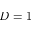Convert formula to latex. <formula><loc_0><loc_0><loc_500><loc_500>D = 1</formula> 